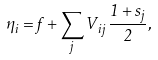<formula> <loc_0><loc_0><loc_500><loc_500>\eta _ { i } = f + \sum _ { j } V _ { i j } \, \frac { 1 + s _ { j } } { 2 } ,</formula> 